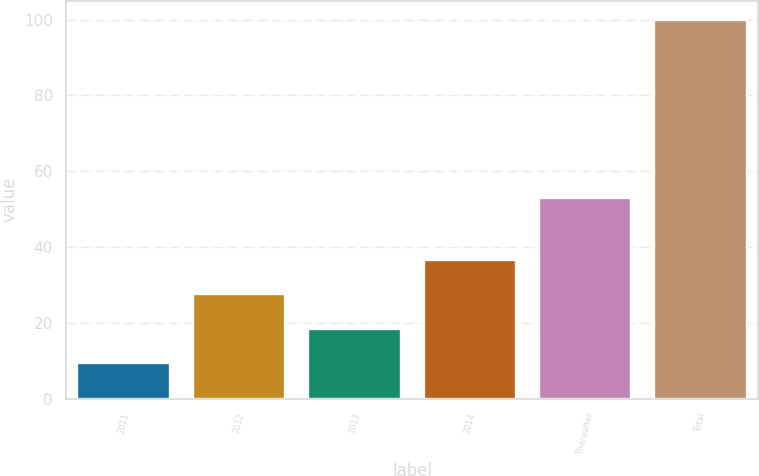Convert chart to OTSL. <chart><loc_0><loc_0><loc_500><loc_500><bar_chart><fcel>2011<fcel>2012<fcel>2013<fcel>2014<fcel>Thereafter<fcel>Total<nl><fcel>9.4<fcel>27.52<fcel>18.46<fcel>36.58<fcel>53<fcel>100<nl></chart> 